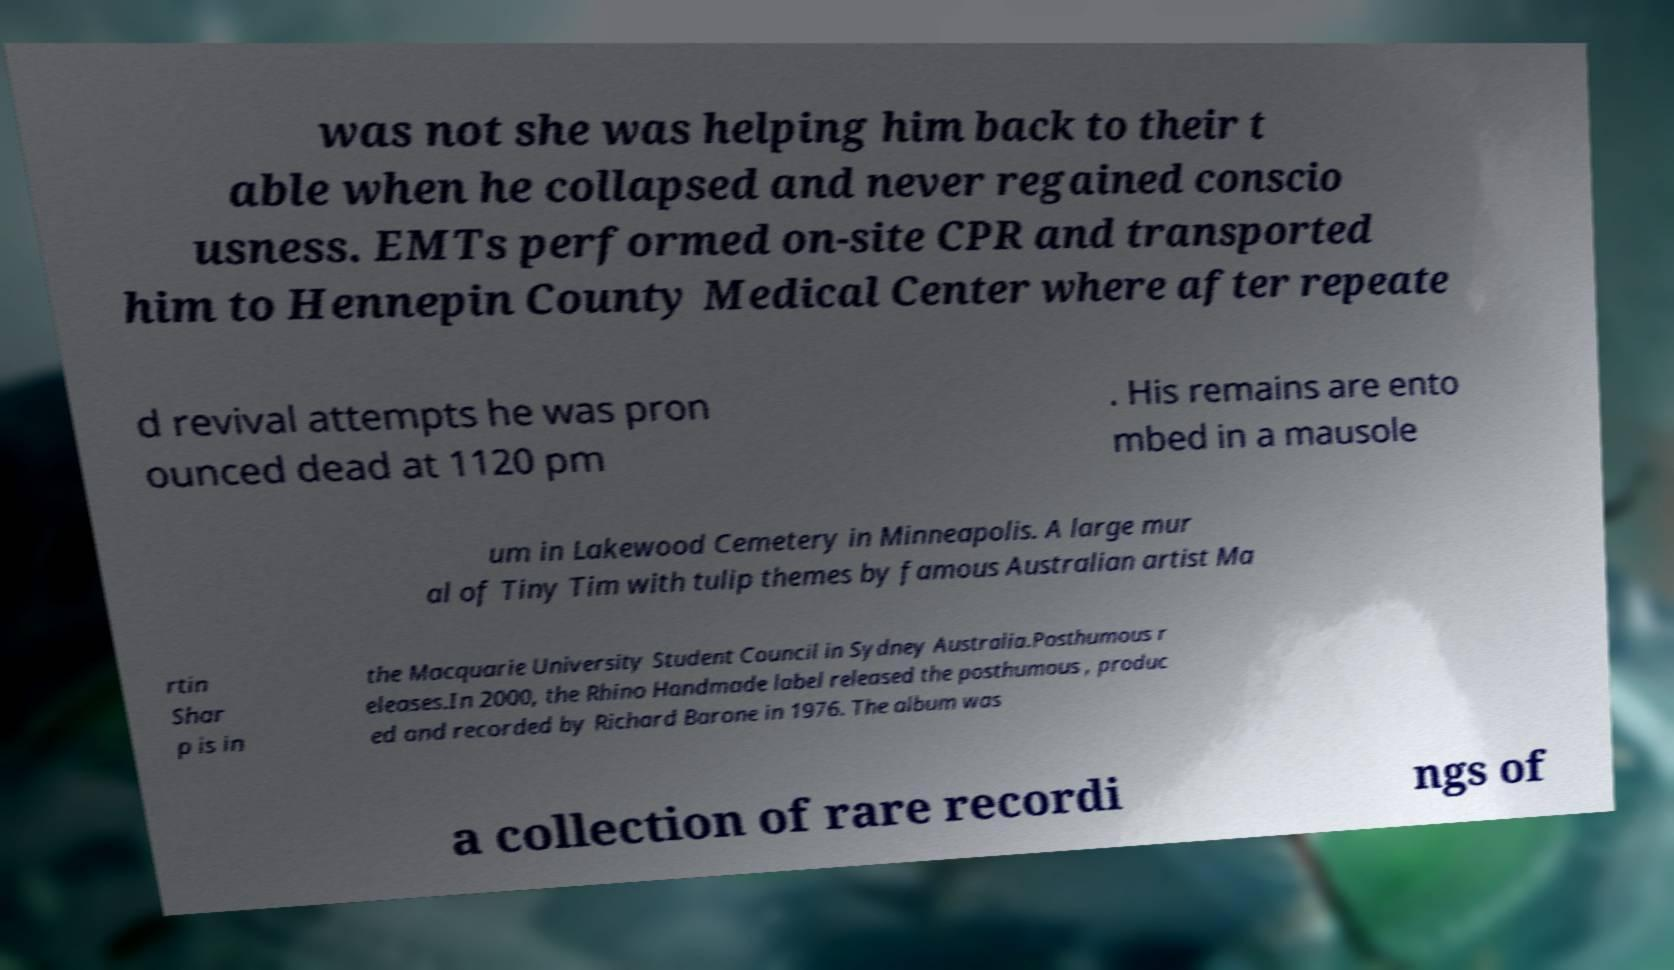For documentation purposes, I need the text within this image transcribed. Could you provide that? was not she was helping him back to their t able when he collapsed and never regained conscio usness. EMTs performed on-site CPR and transported him to Hennepin County Medical Center where after repeate d revival attempts he was pron ounced dead at 1120 pm . His remains are ento mbed in a mausole um in Lakewood Cemetery in Minneapolis. A large mur al of Tiny Tim with tulip themes by famous Australian artist Ma rtin Shar p is in the Macquarie University Student Council in Sydney Australia.Posthumous r eleases.In 2000, the Rhino Handmade label released the posthumous , produc ed and recorded by Richard Barone in 1976. The album was a collection of rare recordi ngs of 